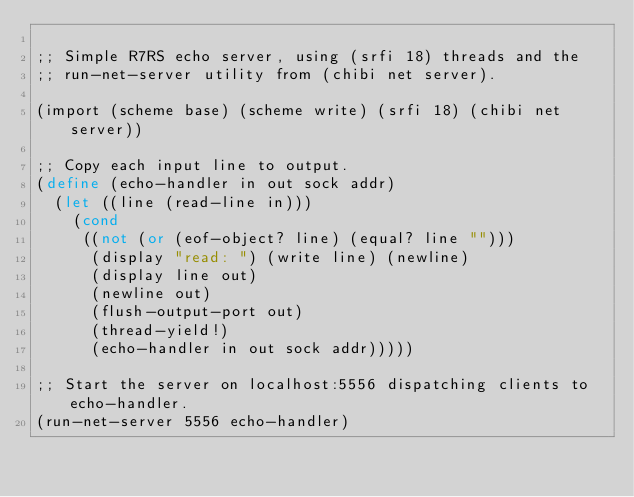<code> <loc_0><loc_0><loc_500><loc_500><_Scheme_>
;; Simple R7RS echo server, using (srfi 18) threads and the
;; run-net-server utility from (chibi net server).

(import (scheme base) (scheme write) (srfi 18) (chibi net server))

;; Copy each input line to output.
(define (echo-handler in out sock addr)
  (let ((line (read-line in)))
    (cond
     ((not (or (eof-object? line) (equal? line "")))
      (display "read: ") (write line) (newline)
      (display line out)
      (newline out)
      (flush-output-port out)
      (thread-yield!)
      (echo-handler in out sock addr)))))

;; Start the server on localhost:5556 dispatching clients to echo-handler.
(run-net-server 5556 echo-handler)
</code> 